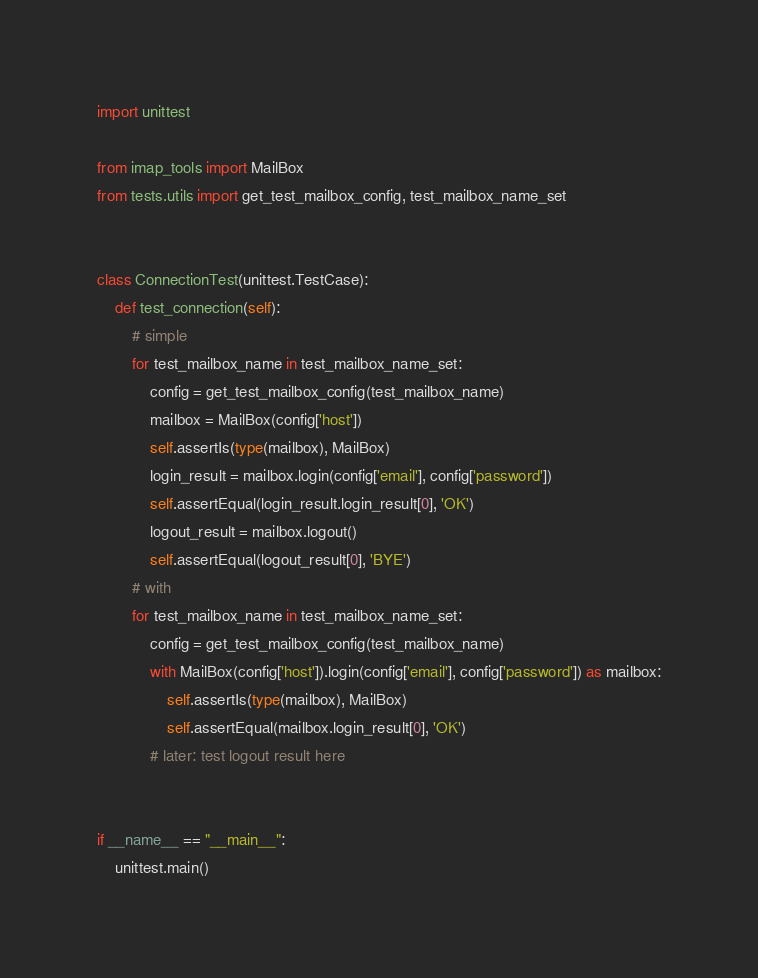Convert code to text. <code><loc_0><loc_0><loc_500><loc_500><_Python_>import unittest

from imap_tools import MailBox
from tests.utils import get_test_mailbox_config, test_mailbox_name_set


class ConnectionTest(unittest.TestCase):
    def test_connection(self):
        # simple
        for test_mailbox_name in test_mailbox_name_set:
            config = get_test_mailbox_config(test_mailbox_name)
            mailbox = MailBox(config['host'])
            self.assertIs(type(mailbox), MailBox)
            login_result = mailbox.login(config['email'], config['password'])
            self.assertEqual(login_result.login_result[0], 'OK')
            logout_result = mailbox.logout()
            self.assertEqual(logout_result[0], 'BYE')
        # with
        for test_mailbox_name in test_mailbox_name_set:
            config = get_test_mailbox_config(test_mailbox_name)
            with MailBox(config['host']).login(config['email'], config['password']) as mailbox:
                self.assertIs(type(mailbox), MailBox)
                self.assertEqual(mailbox.login_result[0], 'OK')
            # later: test logout result here


if __name__ == "__main__":
    unittest.main()
</code> 